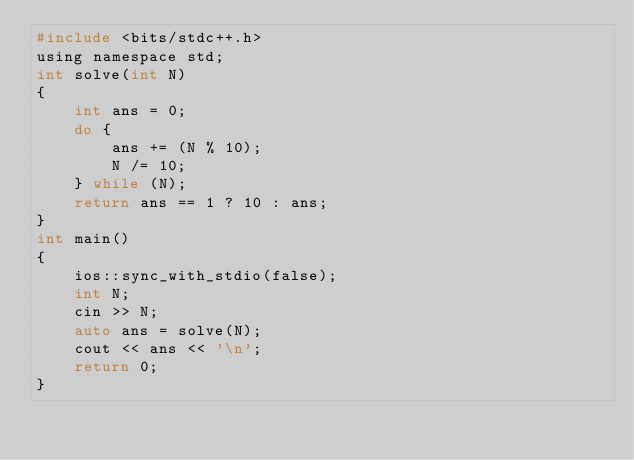Convert code to text. <code><loc_0><loc_0><loc_500><loc_500><_C_>#include <bits/stdc++.h>
using namespace std;
int solve(int N)
{
    int ans = 0;
    do {
        ans += (N % 10);
        N /= 10;
    } while (N);
    return ans == 1 ? 10 : ans;
}
int main()
{
    ios::sync_with_stdio(false);
    int N;
    cin >> N;
    auto ans = solve(N);
    cout << ans << '\n';
    return 0;
}</code> 